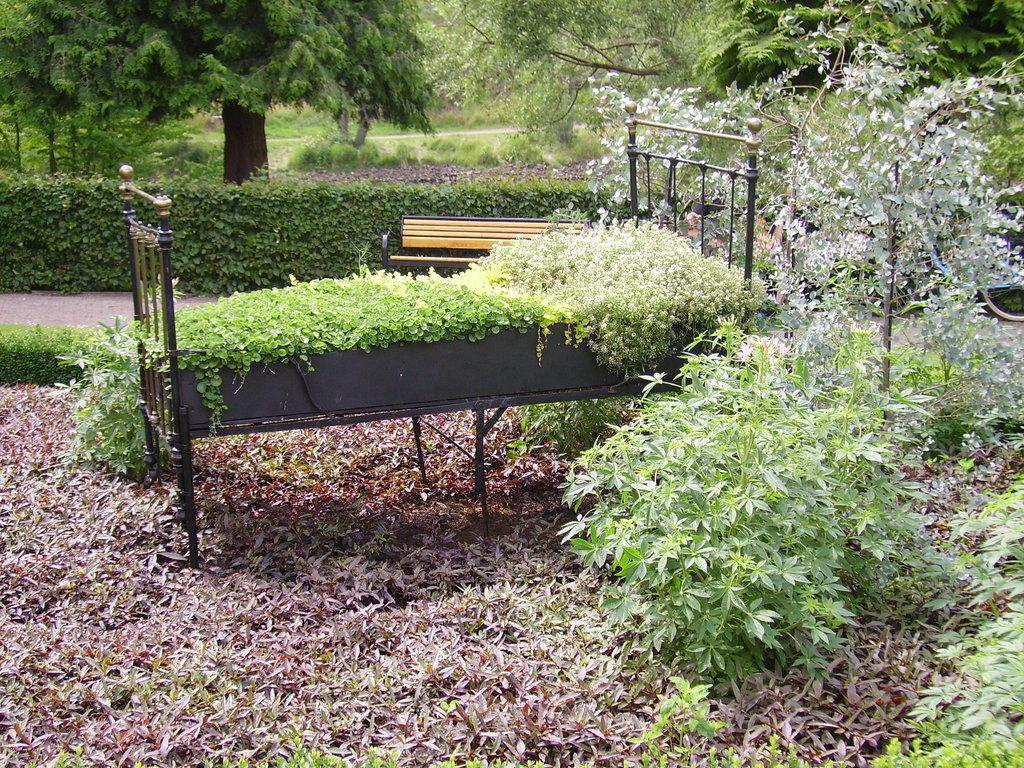What type of vegetation can be seen in the image? There are plants and trees in the image. Can you describe the main object in the middle of the image? There is a cot in the middle of the image. Are there any plants growing on the cot? Yes, climbing plants are present on the cot. How many seats are available on the cot in the image? There are no seats on the cot in the image; it is a cot with climbing plants growing on it. What fact can be learned about the ant population in the image? There is no mention of ants in the image, so no fact about the ant population can be determined. 